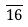<formula> <loc_0><loc_0><loc_500><loc_500>\overline { 1 6 }</formula> 